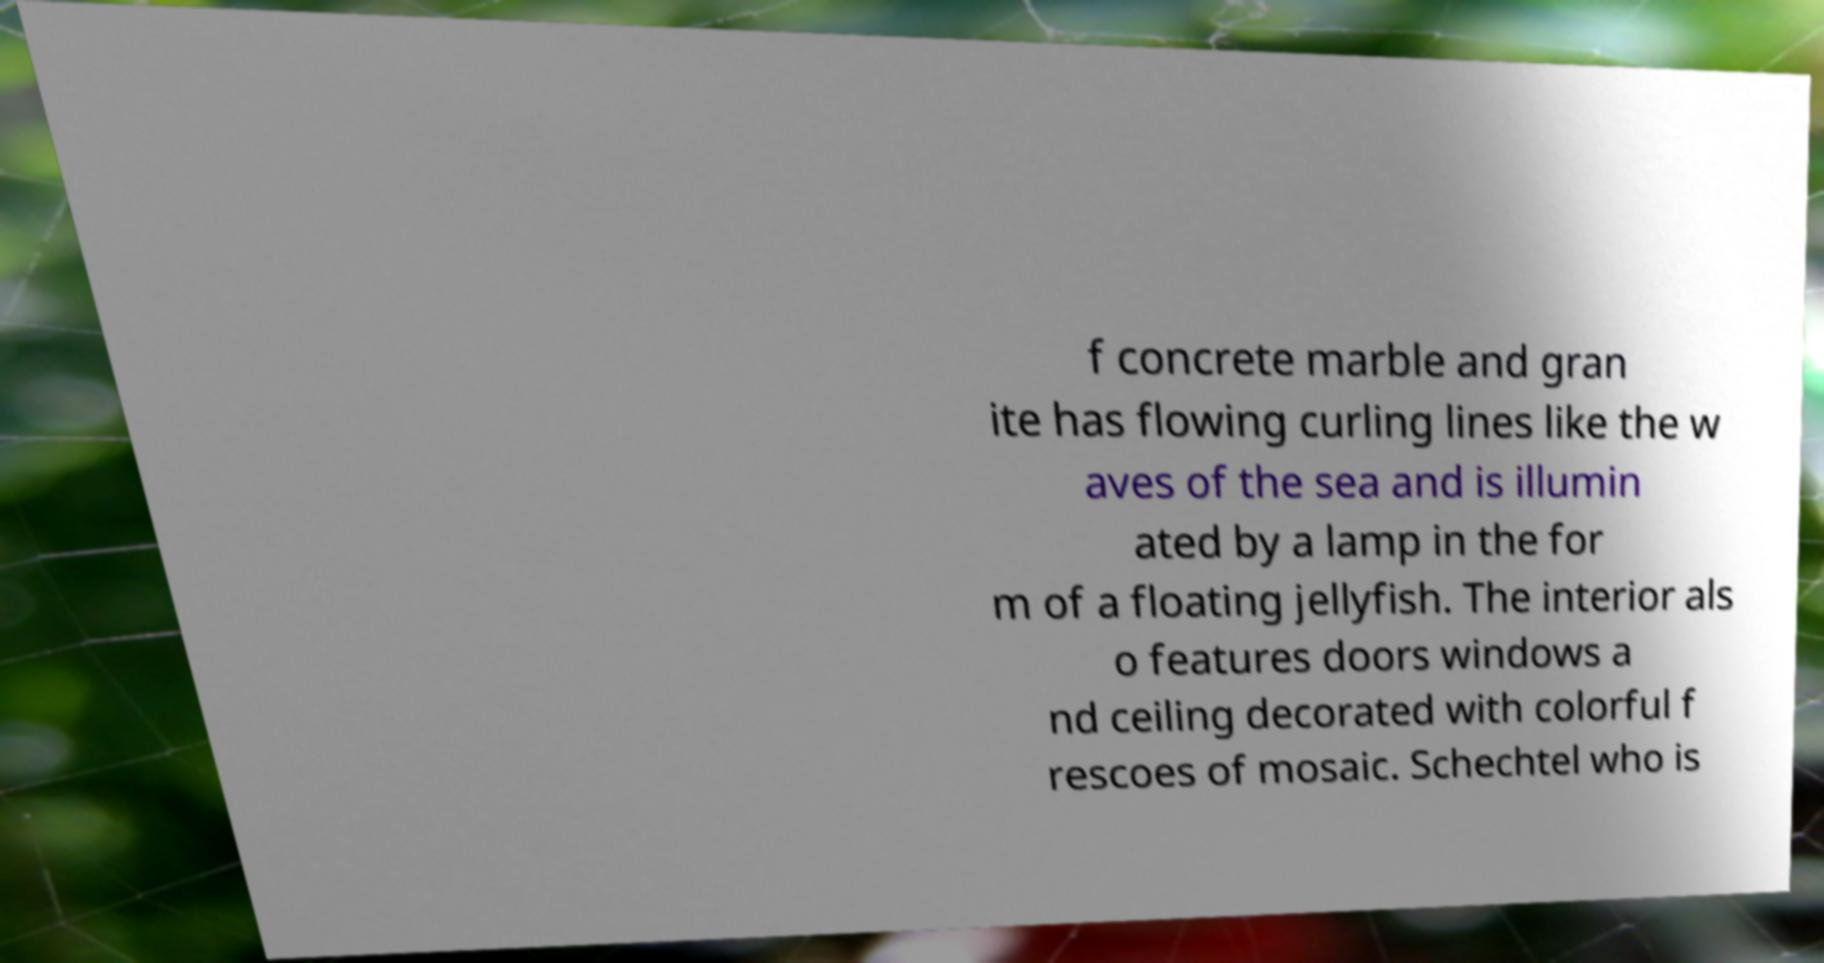Can you accurately transcribe the text from the provided image for me? f concrete marble and gran ite has flowing curling lines like the w aves of the sea and is illumin ated by a lamp in the for m of a floating jellyfish. The interior als o features doors windows a nd ceiling decorated with colorful f rescoes of mosaic. Schechtel who is 